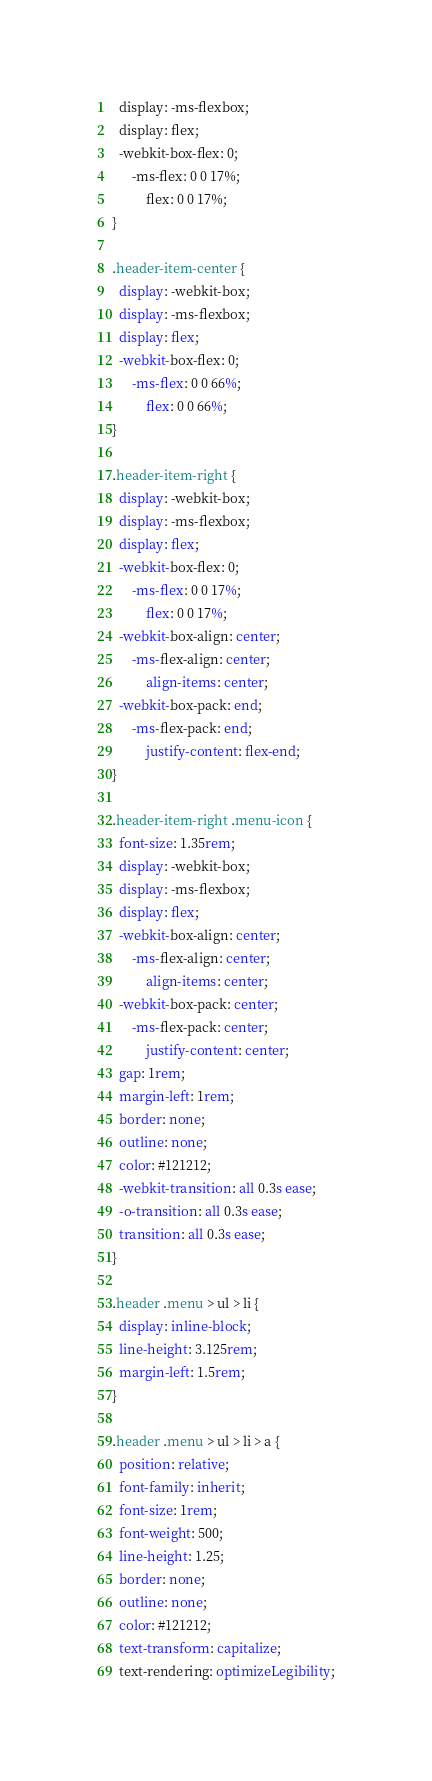<code> <loc_0><loc_0><loc_500><loc_500><_CSS_>  display: -ms-flexbox;
  display: flex;
  -webkit-box-flex: 0;
      -ms-flex: 0 0 17%;
          flex: 0 0 17%;
}

.header-item-center {
  display: -webkit-box;
  display: -ms-flexbox;
  display: flex;
  -webkit-box-flex: 0;
      -ms-flex: 0 0 66%;
          flex: 0 0 66%;
}

.header-item-right {
  display: -webkit-box;
  display: -ms-flexbox;
  display: flex;
  -webkit-box-flex: 0;
      -ms-flex: 0 0 17%;
          flex: 0 0 17%;
  -webkit-box-align: center;
      -ms-flex-align: center;
          align-items: center;
  -webkit-box-pack: end;
      -ms-flex-pack: end;
          justify-content: flex-end;
}

.header-item-right .menu-icon {
  font-size: 1.35rem;
  display: -webkit-box;
  display: -ms-flexbox;
  display: flex;
  -webkit-box-align: center;
      -ms-flex-align: center;
          align-items: center;
  -webkit-box-pack: center;
      -ms-flex-pack: center;
          justify-content: center;
  gap: 1rem;
  margin-left: 1rem;
  border: none;
  outline: none;
  color: #121212;
  -webkit-transition: all 0.3s ease;
  -o-transition: all 0.3s ease;
  transition: all 0.3s ease;
}

.header .menu > ul > li {
  display: inline-block;
  line-height: 3.125rem;
  margin-left: 1.5rem;
}

.header .menu > ul > li > a {
  position: relative;
  font-family: inherit;
  font-size: 1rem;
  font-weight: 500;
  line-height: 1.25;
  border: none;
  outline: none;
  color: #121212;
  text-transform: capitalize;
  text-rendering: optimizeLegibility;</code> 